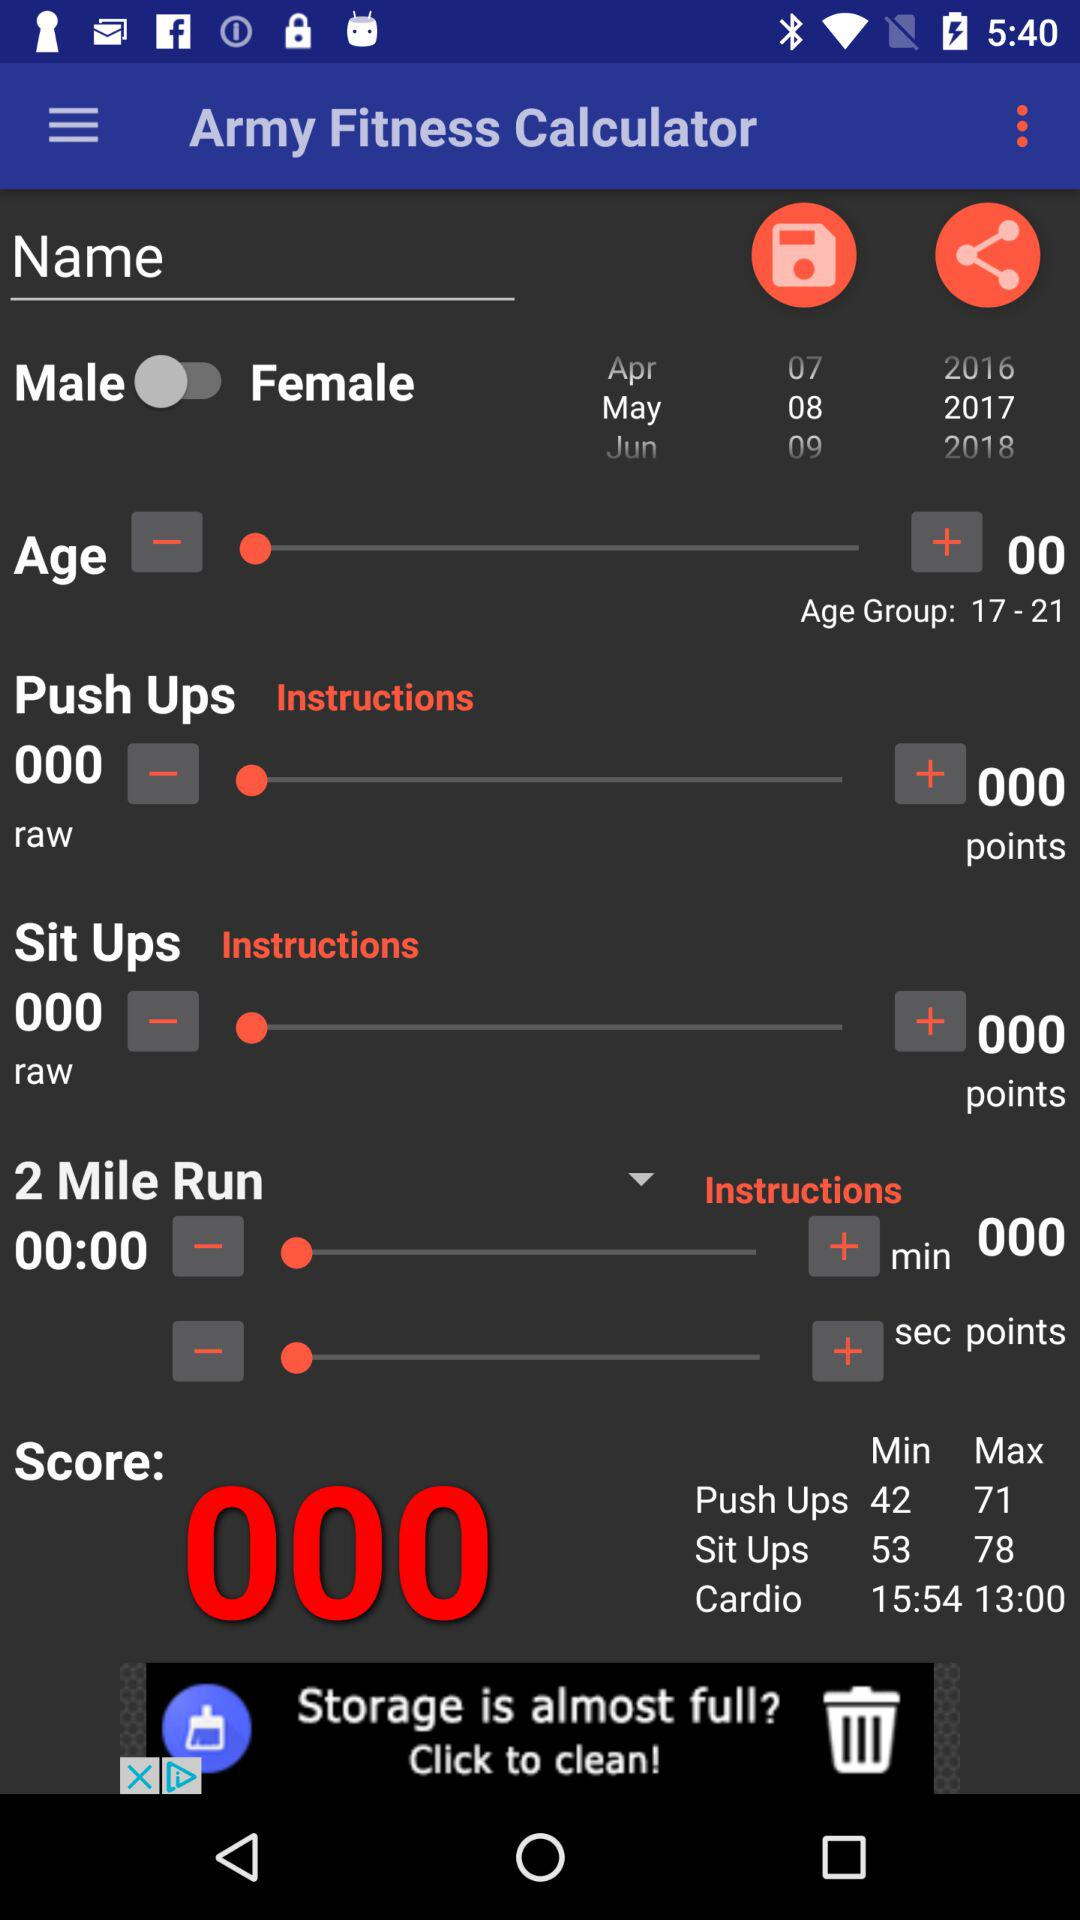What is the age group? The age group is 17 to 21. 